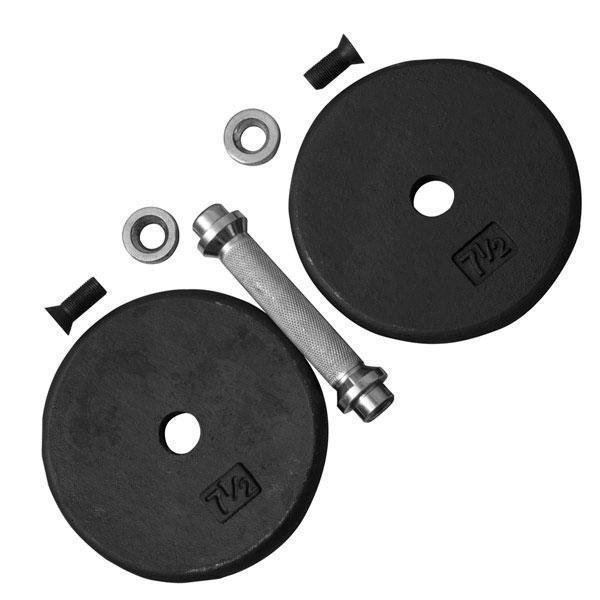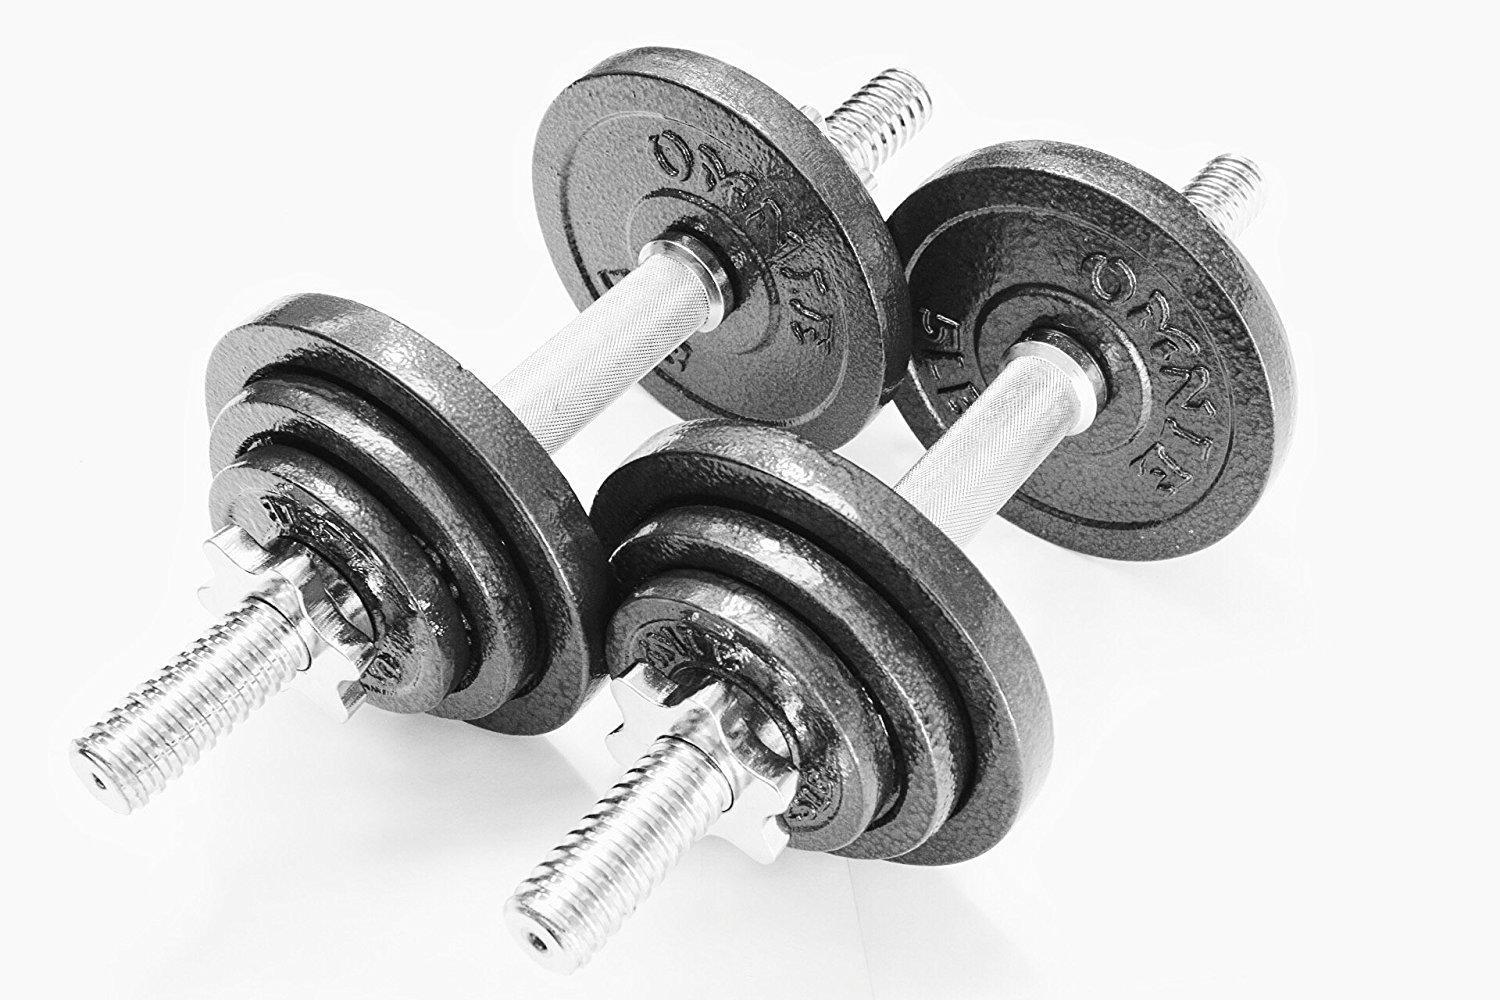The first image is the image on the left, the second image is the image on the right. Considering the images on both sides, is "Both images include separate dumbbell parts that require assembly." valid? Answer yes or no. No. The first image is the image on the left, the second image is the image on the right. Analyze the images presented: Is the assertion "The right image contains the disassembled parts for two barbells." valid? Answer yes or no. No. 